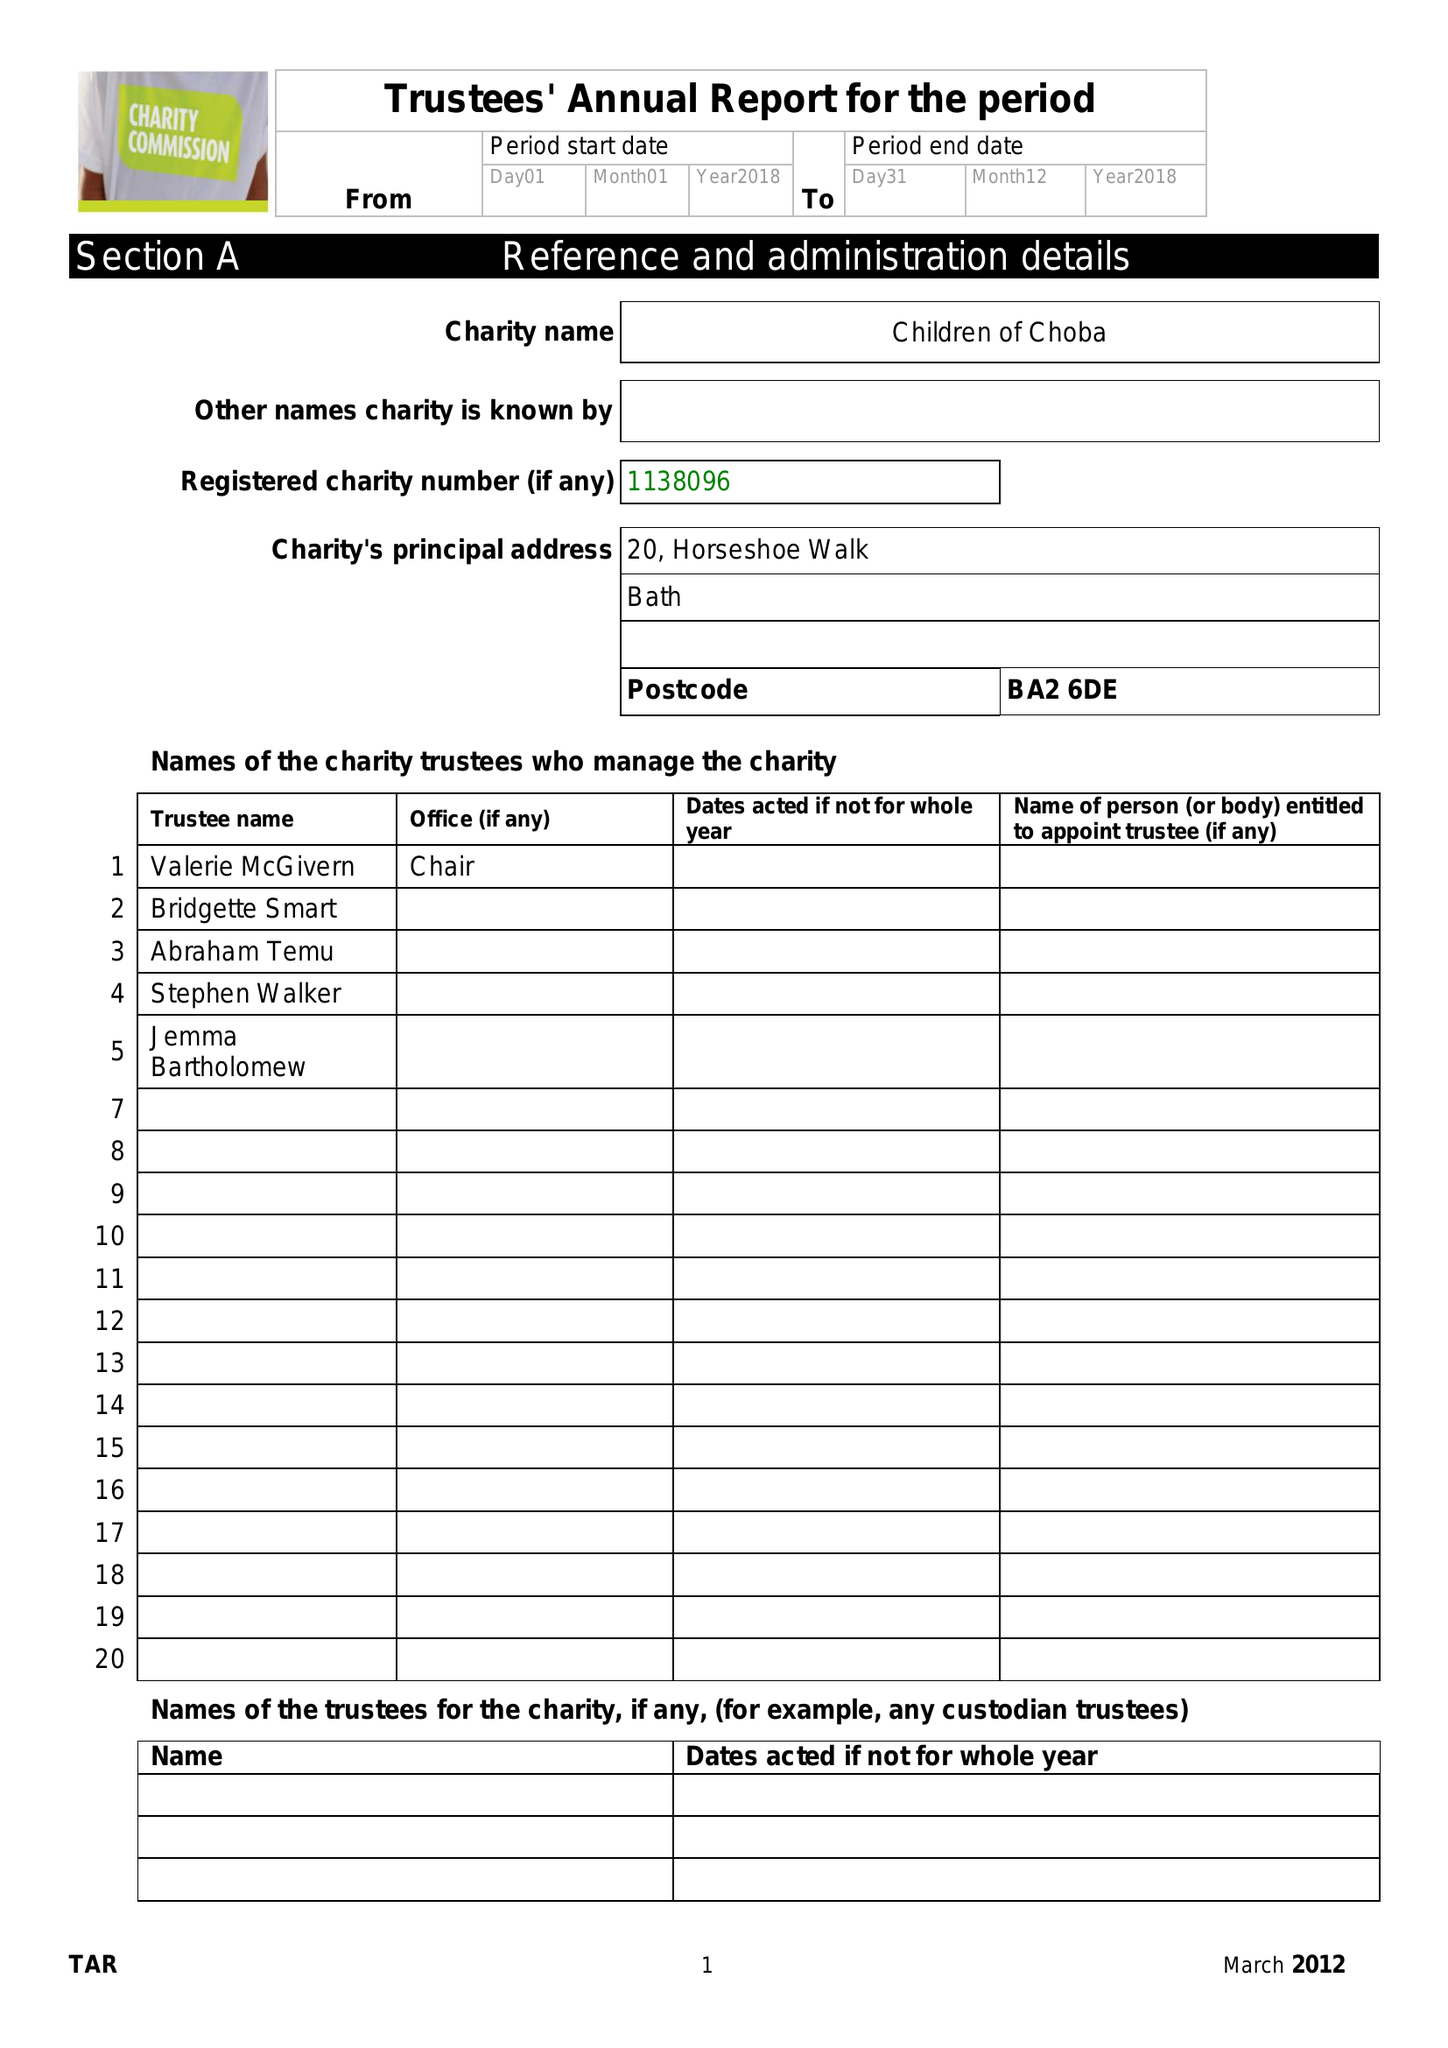What is the value for the report_date?
Answer the question using a single word or phrase. 2018-12-31 